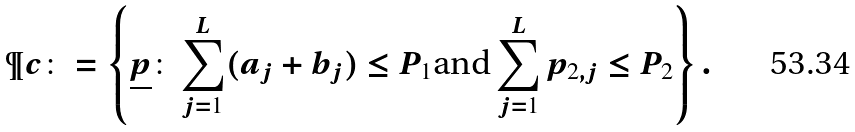<formula> <loc_0><loc_0><loc_500><loc_500>\P c \colon = \left \{ \underline { p } \colon \sum _ { j = 1 } ^ { L } ( a _ { j } + b _ { j } ) \leq P _ { 1 } \text {and} \sum _ { j = 1 } ^ { L } p _ { 2 , j } \leq P _ { 2 } \right \} .</formula> 